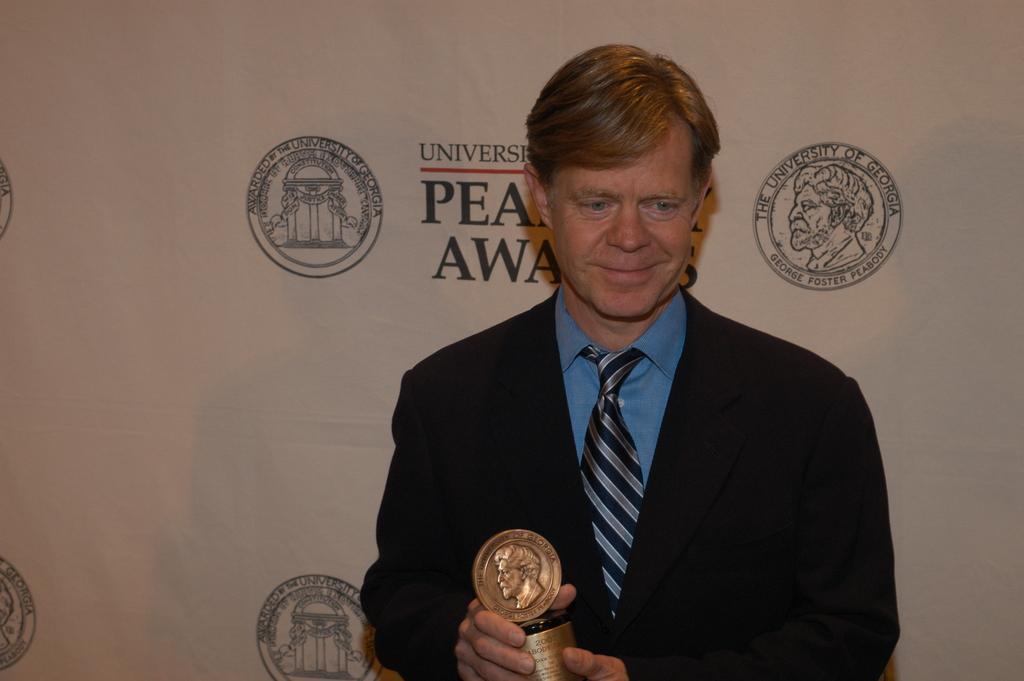Describe this image in one or two sentences. In this image we can see a person wearing blazer, tie and blue color shirt is holding an award. In the background, we can see the banner on which we can see some logos and some text. 